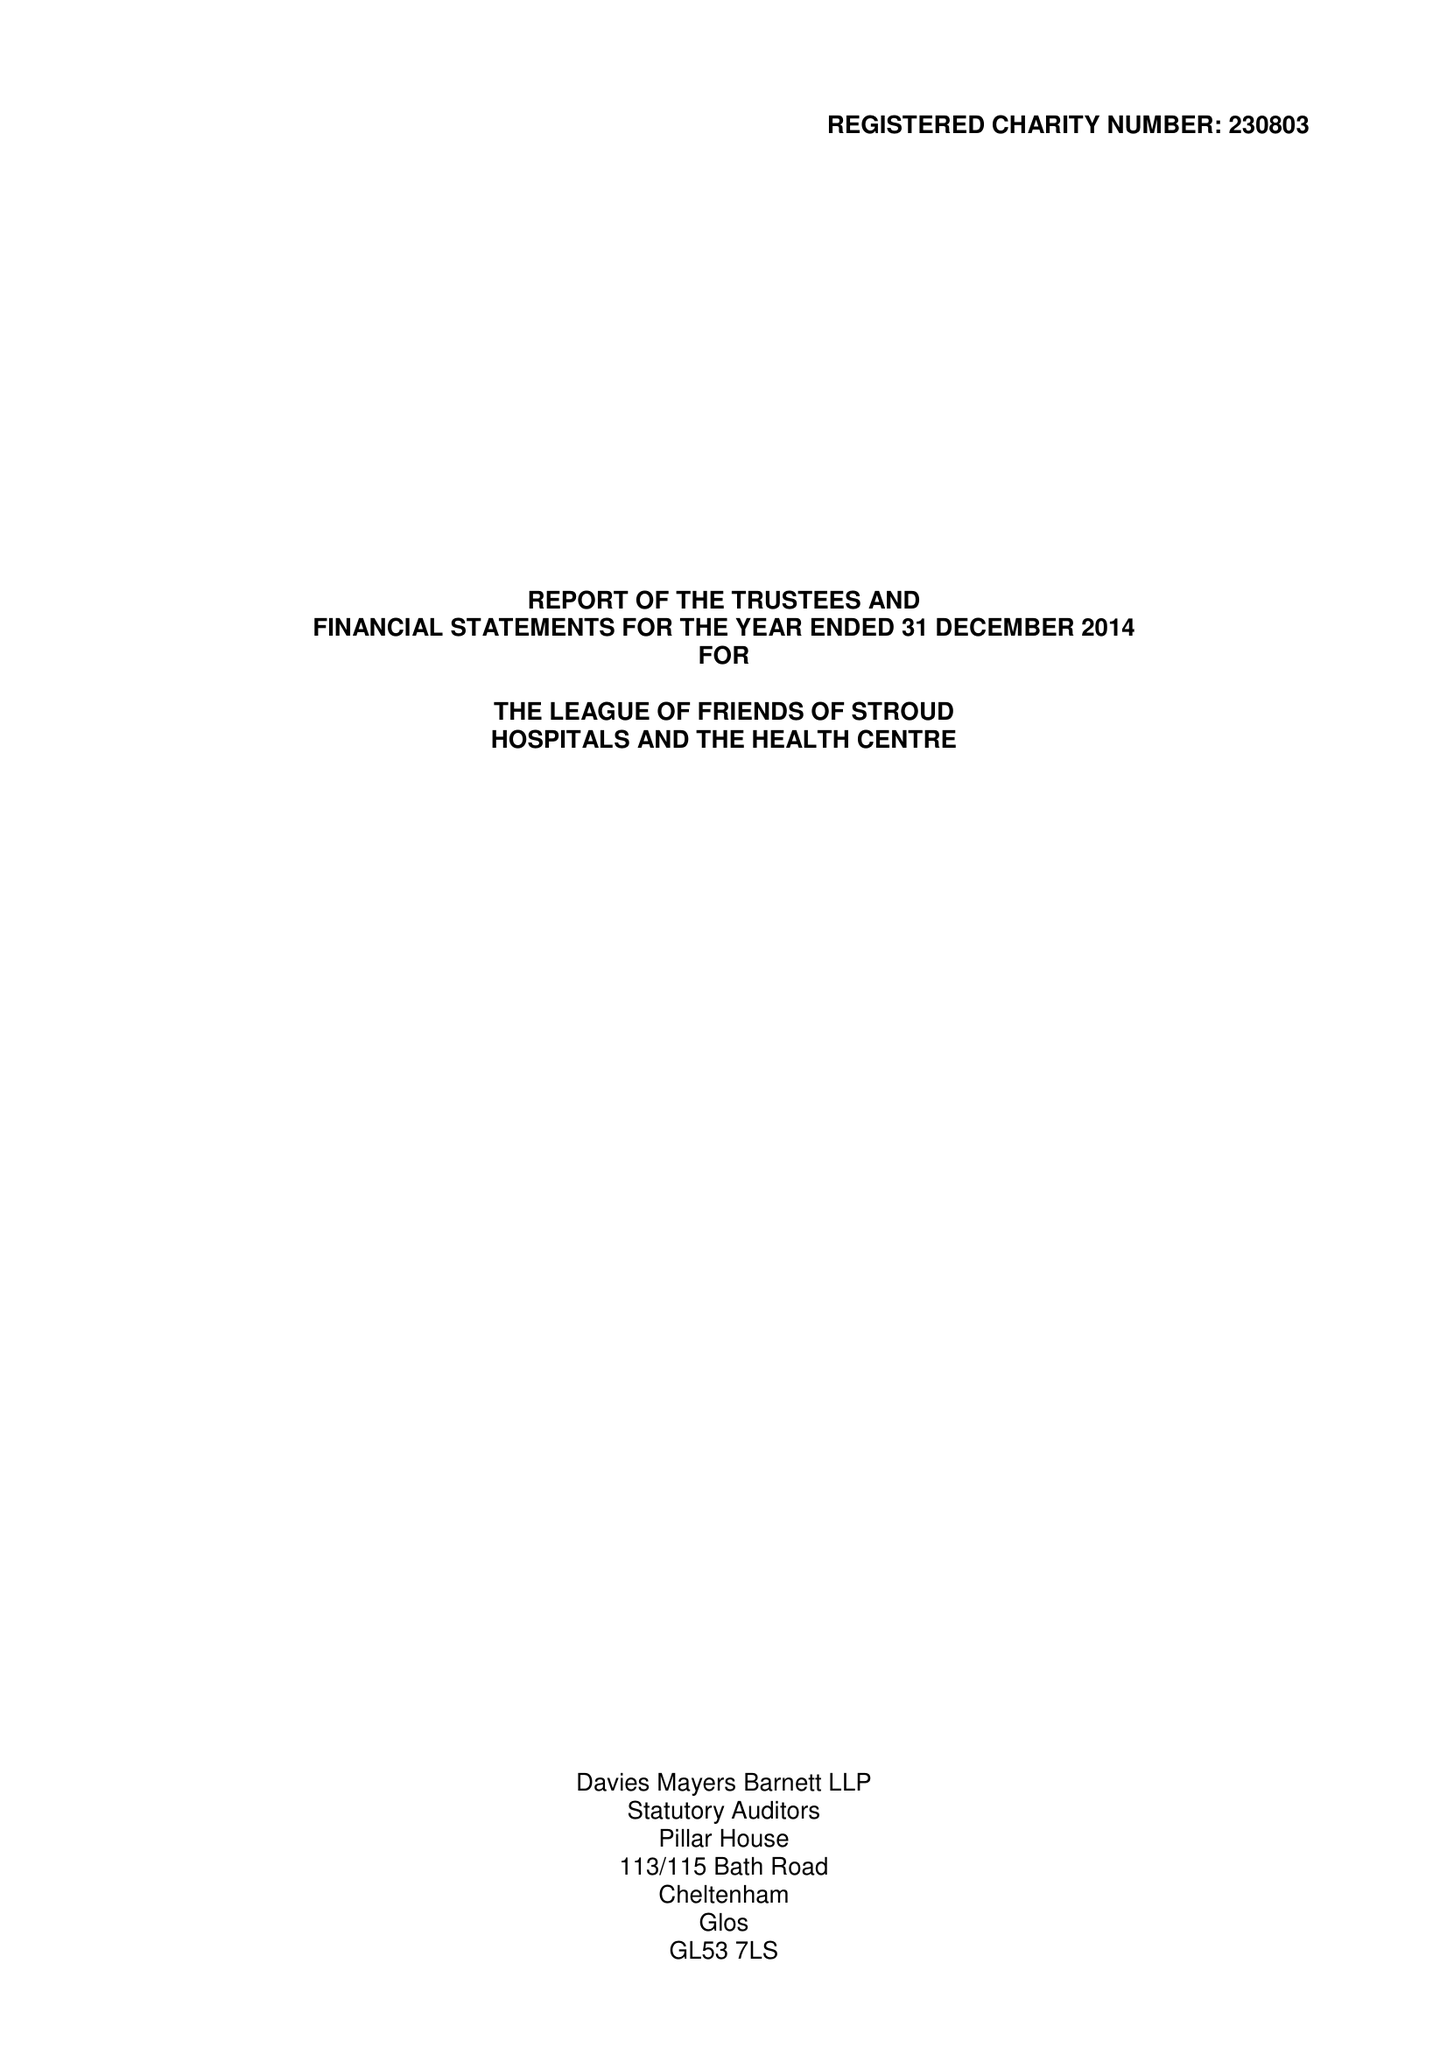What is the value for the spending_annually_in_british_pounds?
Answer the question using a single word or phrase. 196977.00 